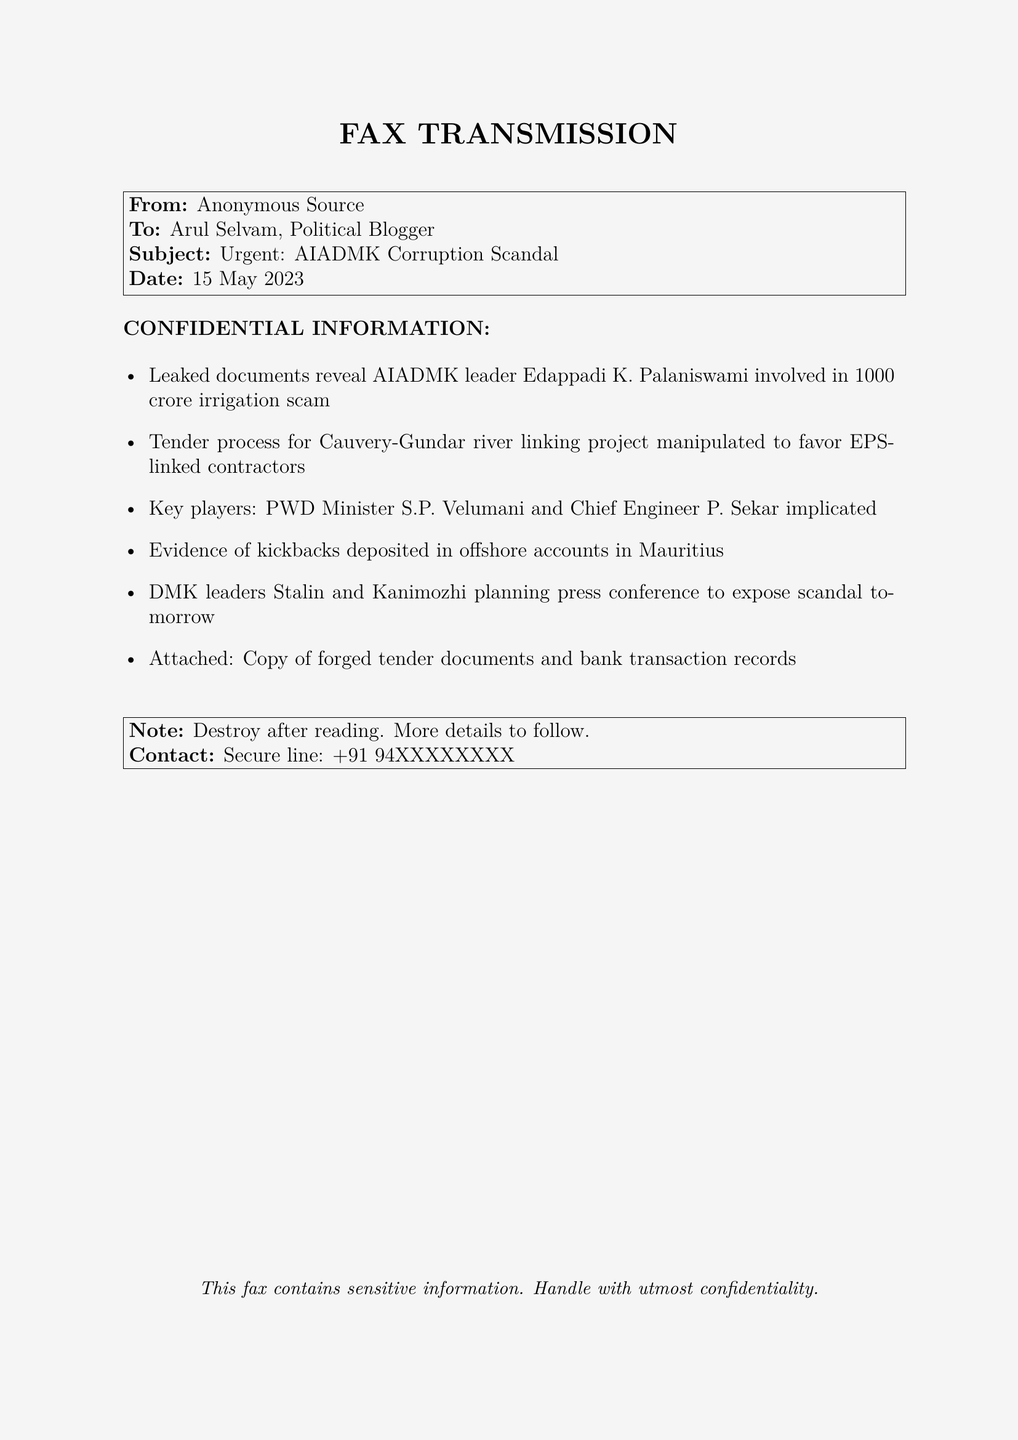What is the amount involved in the irrigation scam? The fax states that the amount involved in the irrigation scam is ₹1000 crore.
Answer: ₹1000 crore Who is the AIADMK leader mentioned in the fax? The fax specifies that the AIADMK leader involved is Edappadi K. Palaniswami.
Answer: Edappadi K. Palaniswami Which project’s tender process was manipulated? The fax indicates that the tender process for the Cauvery-Gundar river linking project was manipulated.
Answer: Cauvery-Gundar river linking project Who are the key players implicated in the scandal? The fax mentions PWD Minister S.P. Velumani and Chief Engineer P. Sekar as the key players implicated.
Answer: S.P. Velumani and P. Sekar What is the date of the fax? The fax includes the date of transmission, which is 15 May 2023.
Answer: 15 May 2023 What is planned by DMK leaders according to the document? The document states that DMK leaders Stalin and Kanimozhi are planning a press conference to expose the scandal.
Answer: Press conference to expose scandal Where were the kickbacks allegedly deposited? The fax claims that the kickbacks were deposited in offshore accounts in Mauritius.
Answer: Offshore accounts in Mauritius What should be done with the fax after reading? The note in the fax advises to destroy the document after reading.
Answer: Destroy after reading 